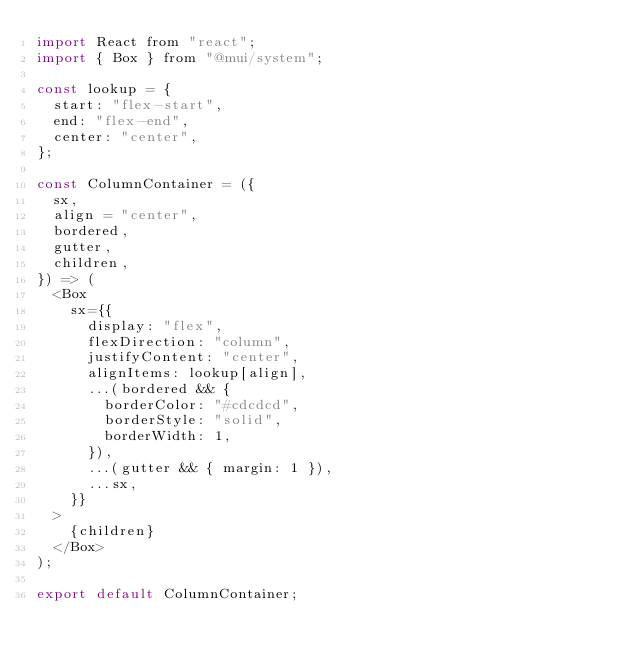<code> <loc_0><loc_0><loc_500><loc_500><_JavaScript_>import React from "react";
import { Box } from "@mui/system";

const lookup = {
  start: "flex-start",
  end: "flex-end",
  center: "center",
};

const ColumnContainer = ({
  sx,
  align = "center",
  bordered,
  gutter,
  children,
}) => (
  <Box
    sx={{
      display: "flex",
      flexDirection: "column",
      justifyContent: "center",
      alignItems: lookup[align],
      ...(bordered && {
        borderColor: "#cdcdcd",
        borderStyle: "solid",
        borderWidth: 1,
      }),
      ...(gutter && { margin: 1 }),
      ...sx,
    }}
  >
    {children}
  </Box>
);

export default ColumnContainer;
</code> 